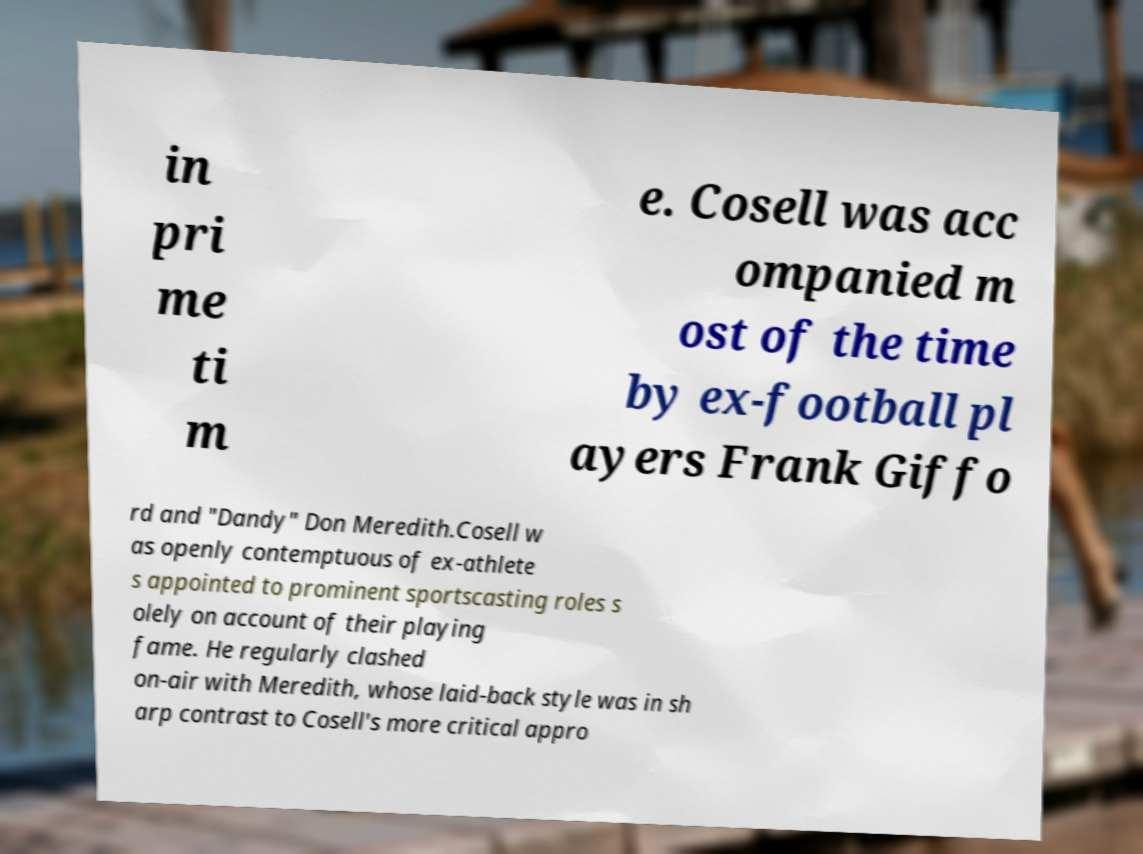For documentation purposes, I need the text within this image transcribed. Could you provide that? in pri me ti m e. Cosell was acc ompanied m ost of the time by ex-football pl ayers Frank Giffo rd and "Dandy" Don Meredith.Cosell w as openly contemptuous of ex-athlete s appointed to prominent sportscasting roles s olely on account of their playing fame. He regularly clashed on-air with Meredith, whose laid-back style was in sh arp contrast to Cosell's more critical appro 